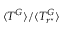<formula> <loc_0><loc_0><loc_500><loc_500>\langle T ^ { G } \rangle / \langle T _ { r ^ { ^ { * } } } ^ { G } \rangle</formula> 